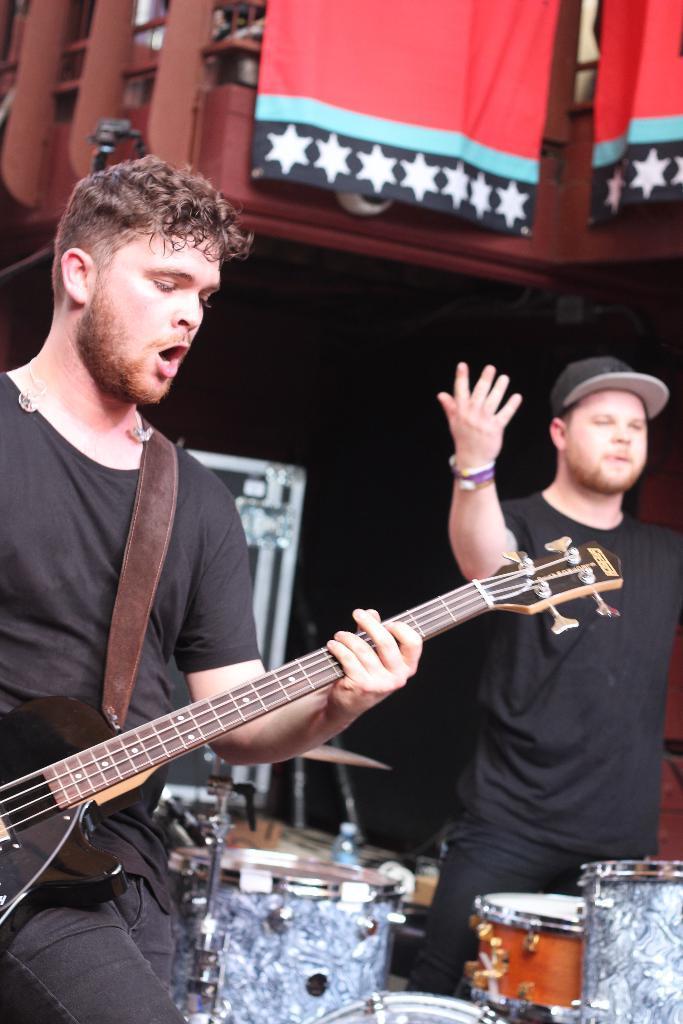In one or two sentences, can you explain what this image depicts? There are two people standing and this man playing a guitar and we can see musical instruments. In the background it is dark and we can see flags. 